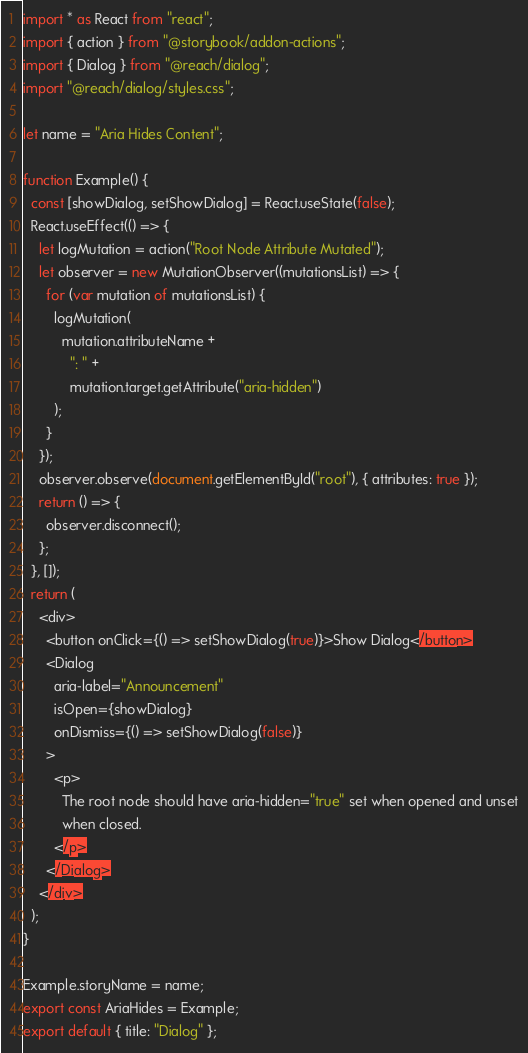<code> <loc_0><loc_0><loc_500><loc_500><_JavaScript_>import * as React from "react";
import { action } from "@storybook/addon-actions";
import { Dialog } from "@reach/dialog";
import "@reach/dialog/styles.css";

let name = "Aria Hides Content";

function Example() {
  const [showDialog, setShowDialog] = React.useState(false);
  React.useEffect(() => {
    let logMutation = action("Root Node Attribute Mutated");
    let observer = new MutationObserver((mutationsList) => {
      for (var mutation of mutationsList) {
        logMutation(
          mutation.attributeName +
            ": " +
            mutation.target.getAttribute("aria-hidden")
        );
      }
    });
    observer.observe(document.getElementById("root"), { attributes: true });
    return () => {
      observer.disconnect();
    };
  }, []);
  return (
    <div>
      <button onClick={() => setShowDialog(true)}>Show Dialog</button>
      <Dialog
        aria-label="Announcement"
        isOpen={showDialog}
        onDismiss={() => setShowDialog(false)}
      >
        <p>
          The root node should have aria-hidden="true" set when opened and unset
          when closed.
        </p>
      </Dialog>
    </div>
  );
}

Example.storyName = name;
export const AriaHides = Example;
export default { title: "Dialog" };
</code> 